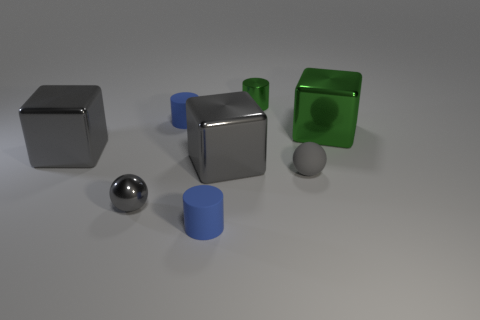Add 1 large brown rubber blocks. How many objects exist? 9 Subtract all blocks. How many objects are left? 5 Add 6 matte spheres. How many matte spheres are left? 7 Add 2 large blocks. How many large blocks exist? 5 Subtract 0 cyan cylinders. How many objects are left? 8 Subtract all tiny blue shiny spheres. Subtract all green metal things. How many objects are left? 6 